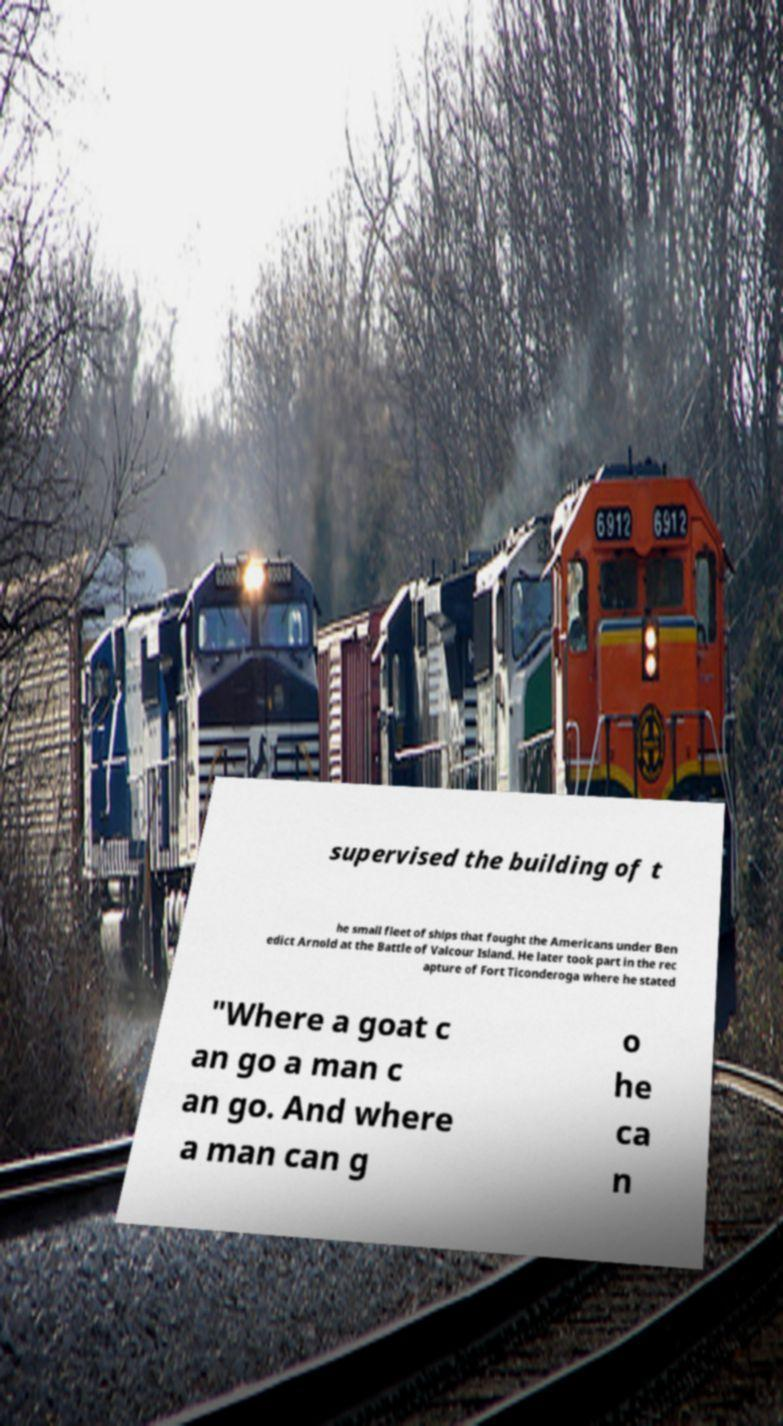Could you extract and type out the text from this image? supervised the building of t he small fleet of ships that fought the Americans under Ben edict Arnold at the Battle of Valcour Island. He later took part in the rec apture of Fort Ticonderoga where he stated "Where a goat c an go a man c an go. And where a man can g o he ca n 